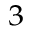<formula> <loc_0><loc_0><loc_500><loc_500>^ { 3 }</formula> 